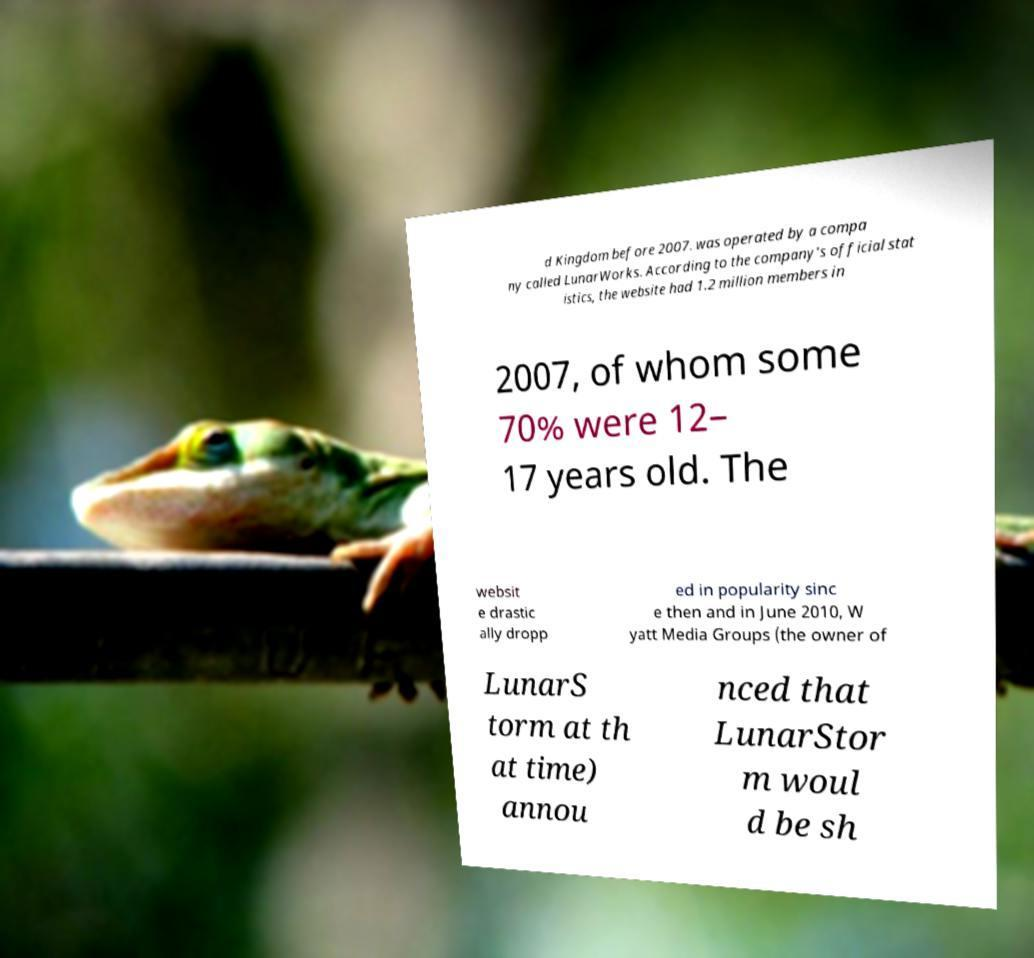There's text embedded in this image that I need extracted. Can you transcribe it verbatim? d Kingdom before 2007. was operated by a compa ny called LunarWorks. According to the company's official stat istics, the website had 1.2 million members in 2007, of whom some 70% were 12– 17 years old. The websit e drastic ally dropp ed in popularity sinc e then and in June 2010, W yatt Media Groups (the owner of LunarS torm at th at time) annou nced that LunarStor m woul d be sh 